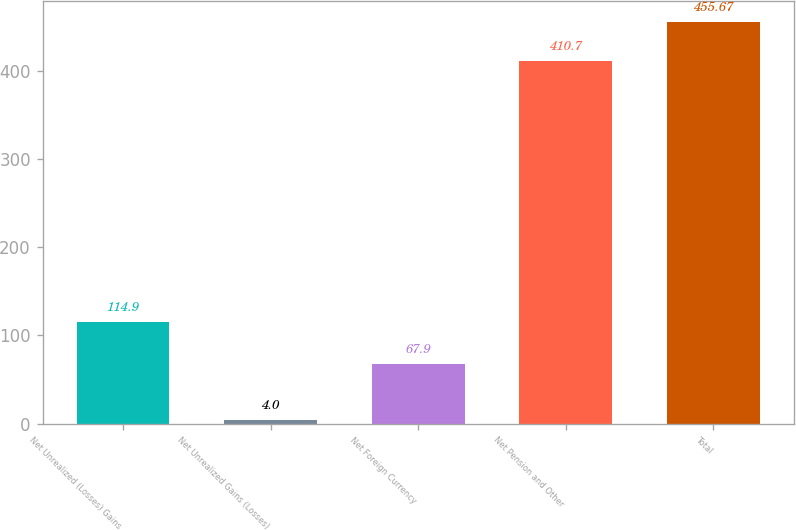<chart> <loc_0><loc_0><loc_500><loc_500><bar_chart><fcel>Net Unrealized (Losses) Gains<fcel>Net Unrealized Gains (Losses)<fcel>Net Foreign Currency<fcel>Net Pension and Other<fcel>Total<nl><fcel>114.9<fcel>4<fcel>67.9<fcel>410.7<fcel>455.67<nl></chart> 